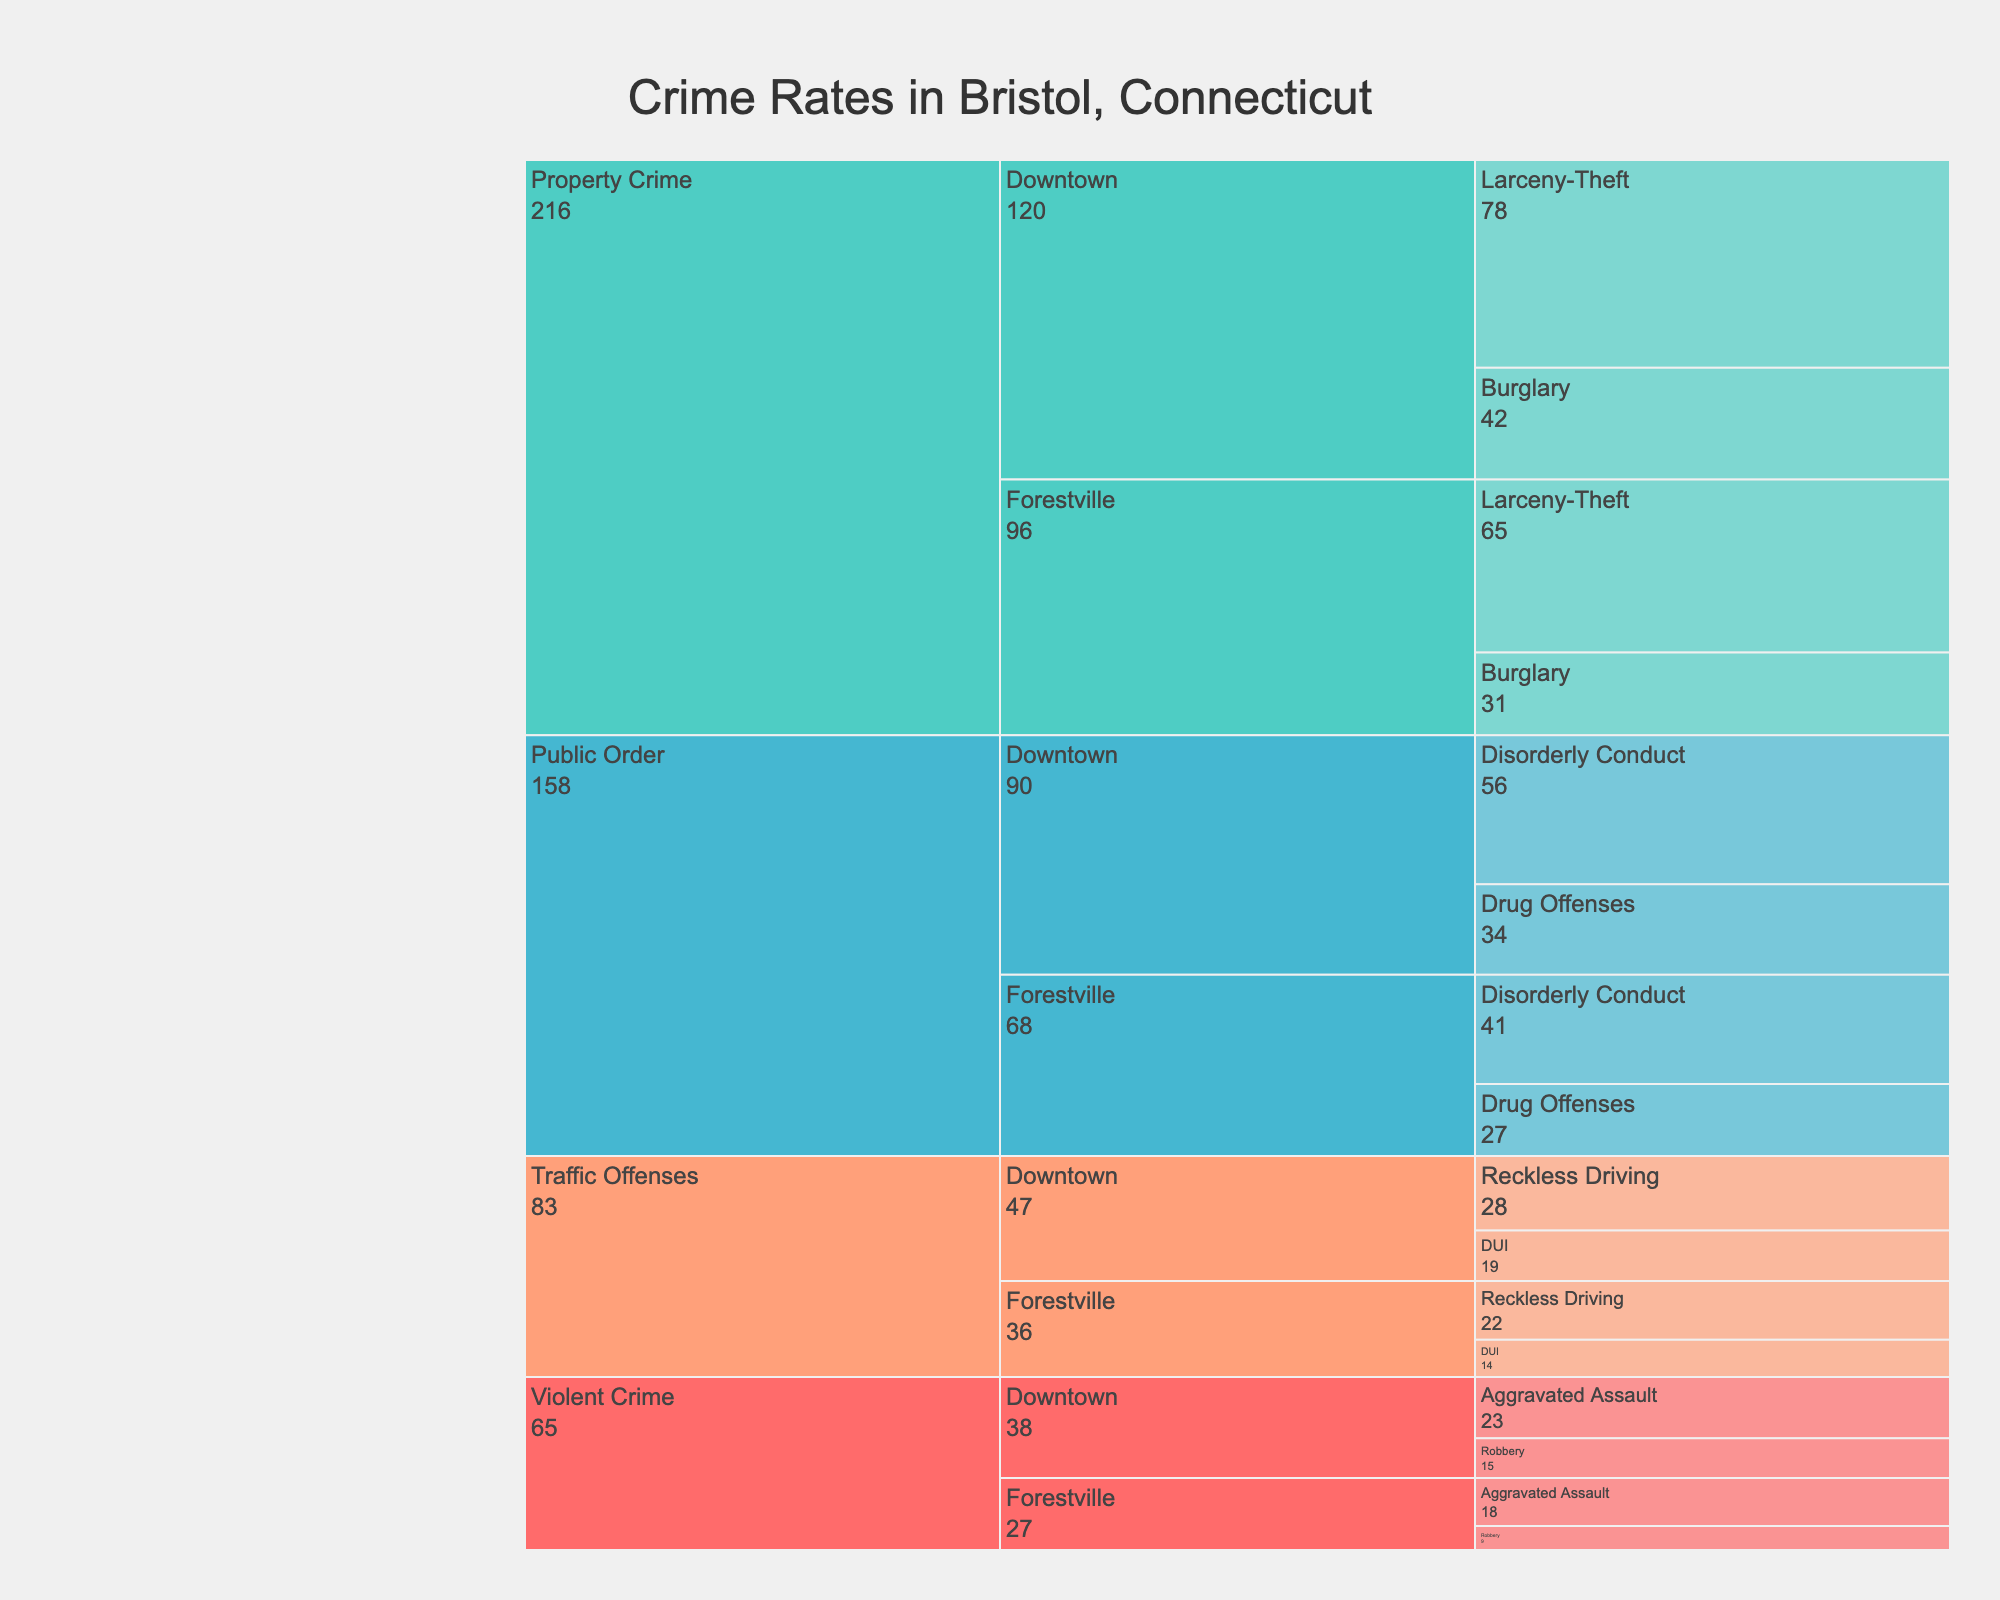What are the four main crime types categorized in the chart? The four main crime types are shown as the first level of categories in the Icicle chart. These are "Violent Crime," "Property Crime," "Public Order," and "Traffic Offenses."
Answer: Violent Crime, Property Crime, Public Order, Traffic Offenses Which neighborhood has more Public Order offenses, Downtown or Forestville? To determine this, compare the counts of Public Order offenses in both neighborhoods. Downtown has Disorderly Conduct (56) + Drug Offenses (34) = 90, while Forestville has Disorderly Conduct (41) + Drug Offenses (27) = 68.
Answer: Downtown What is the total number of Property Crimes in Bristol? Add up all counts of Property Crimes in both neighborhoods: Downtown Burglary (42) + Downtown Larceny-Theft (78) + Forestville Burglary (31) + Forestville Larceny-Theft (65). That equals 42 + 78 + 31 + 65 = 216.
Answer: 216 How many more Larceny-Theft incidents are there in Downtown compared to Forestville? Subtract the number of Larceny-Theft incidents in Forestville from those in Downtown: 78 (Downtown) - 65 (Forestville) = 13.
Answer: 13 Which type of offense is the most frequent in Forestville? In the Icicle chart, the offenses are broken down by neighborhood and then by type. Check the counts for each offense in Forestville. Larceny-Theft has the highest count at 65.
Answer: Larceny-Theft Between Aggravated Assault and Robbery, which has higher counts in the Downtown neighborhood? Compare the counts of Aggravated Assault (23) and Robbery (15) in Downtown. Aggravated Assault is higher.
Answer: Aggravated Assault How many total Traffic Offenses are recorded in the chart? Sum up the counts of all Traffic Offenses in both neighborhoods: Downtown DUI (19) + Downtown Reckless Driving (28) + Forestville DUI (14) + Forestville Reckless Driving (22). That equals 19 + 28 + 14 + 22 = 83.
Answer: 83 Which neighborhood has fewer Violent Crimes, Downtown or Forestville? Add up the Violent Crimes for both neighborhoods and compare: Downtown has Aggravated Assault (23) + Robbery (15) = 38, and Forestville has Aggravated Assault (18) + Robbery (9) = 27. Forestville has fewer Violent Crimes.
Answer: Forestville 